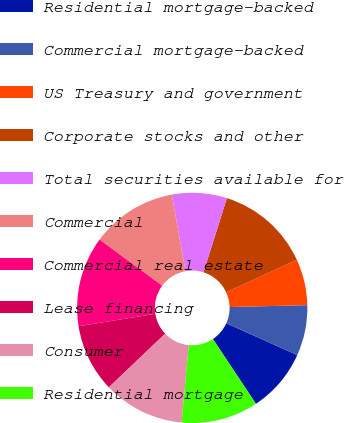<chart> <loc_0><loc_0><loc_500><loc_500><pie_chart><fcel>Residential mortgage-backed<fcel>Commercial mortgage-backed<fcel>US Treasury and government<fcel>Corporate stocks and other<fcel>Total securities available for<fcel>Commercial<fcel>Commercial real estate<fcel>Lease financing<fcel>Consumer<fcel>Residential mortgage<nl><fcel>8.95%<fcel>7.1%<fcel>6.48%<fcel>13.27%<fcel>7.72%<fcel>12.04%<fcel>12.65%<fcel>9.57%<fcel>11.42%<fcel>10.8%<nl></chart> 